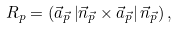Convert formula to latex. <formula><loc_0><loc_0><loc_500><loc_500>R _ { p } = \left ( \vec { a } _ { \vec { p } } \left | \vec { n } _ { \vec { p } } \times \vec { a } _ { \vec { p } } \right | \vec { n } _ { \vec { p } } \right ) ,</formula> 